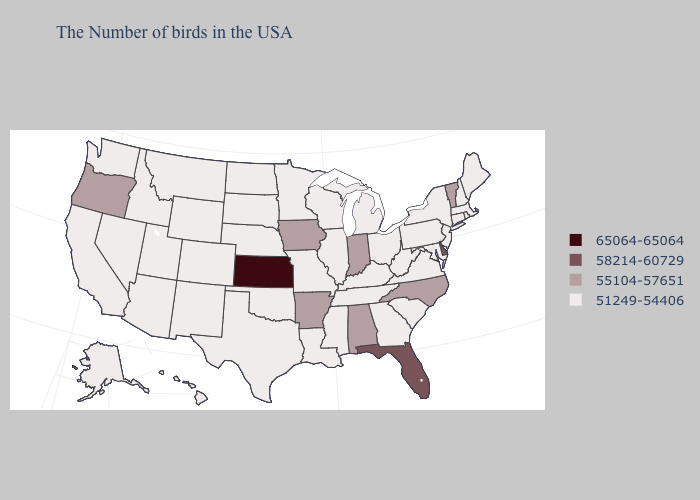Which states have the lowest value in the MidWest?
Concise answer only. Ohio, Michigan, Wisconsin, Illinois, Missouri, Minnesota, Nebraska, South Dakota, North Dakota. Name the states that have a value in the range 55104-57651?
Quick response, please. Vermont, North Carolina, Indiana, Alabama, Arkansas, Iowa, Oregon. Which states have the lowest value in the USA?
Give a very brief answer. Maine, Massachusetts, Rhode Island, New Hampshire, Connecticut, New York, New Jersey, Maryland, Pennsylvania, Virginia, South Carolina, West Virginia, Ohio, Georgia, Michigan, Kentucky, Tennessee, Wisconsin, Illinois, Mississippi, Louisiana, Missouri, Minnesota, Nebraska, Oklahoma, Texas, South Dakota, North Dakota, Wyoming, Colorado, New Mexico, Utah, Montana, Arizona, Idaho, Nevada, California, Washington, Alaska, Hawaii. What is the highest value in states that border Louisiana?
Answer briefly. 55104-57651. Which states have the lowest value in the MidWest?
Be succinct. Ohio, Michigan, Wisconsin, Illinois, Missouri, Minnesota, Nebraska, South Dakota, North Dakota. What is the highest value in states that border Illinois?
Short answer required. 55104-57651. What is the value of Idaho?
Be succinct. 51249-54406. Does the first symbol in the legend represent the smallest category?
Quick response, please. No. What is the value of Oregon?
Write a very short answer. 55104-57651. What is the value of Connecticut?
Answer briefly. 51249-54406. What is the value of Ohio?
Concise answer only. 51249-54406. What is the value of Rhode Island?
Be succinct. 51249-54406. Does Wyoming have the same value as North Carolina?
Concise answer only. No. What is the value of Maine?
Write a very short answer. 51249-54406. 